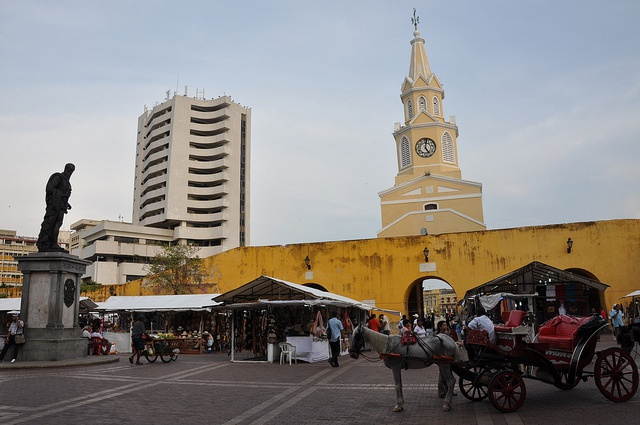Describe the objects in this image and their specific colors. I can see horse in darkgray, black, gray, and maroon tones, people in darkgray, black, gray, olive, and maroon tones, people in darkgray, black, and gray tones, people in darkgray, black, and gray tones, and people in darkgray, black, gray, and maroon tones in this image. 